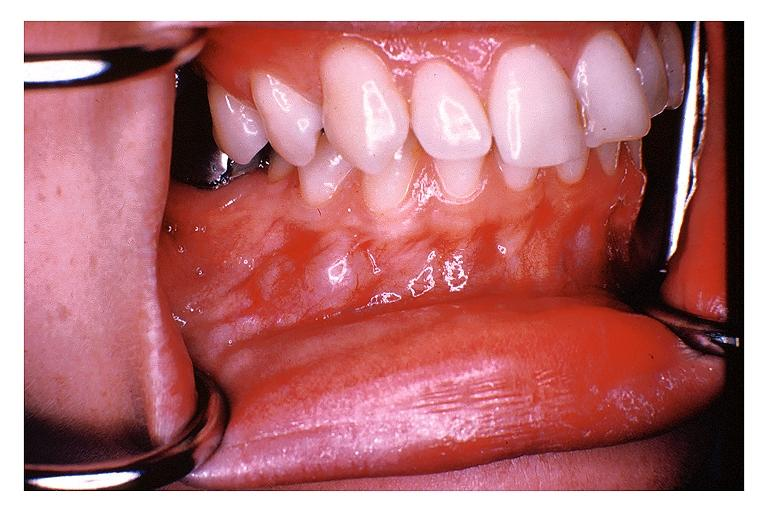s oral present?
Answer the question using a single word or phrase. Yes 